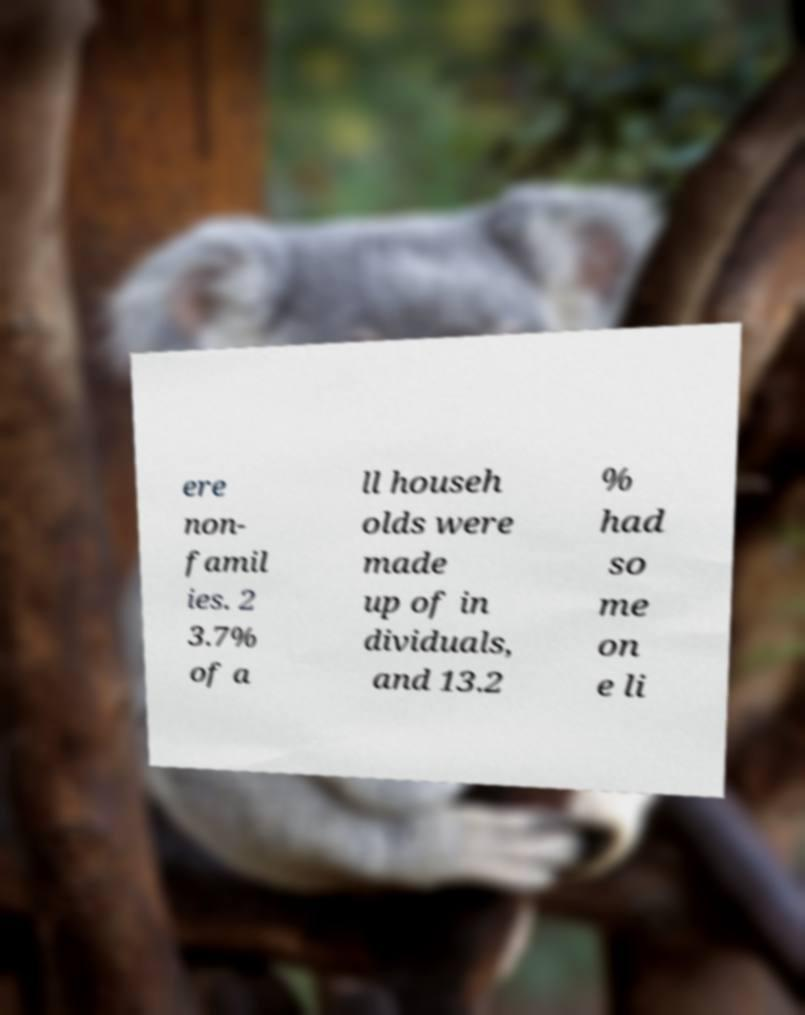For documentation purposes, I need the text within this image transcribed. Could you provide that? ere non- famil ies. 2 3.7% of a ll househ olds were made up of in dividuals, and 13.2 % had so me on e li 